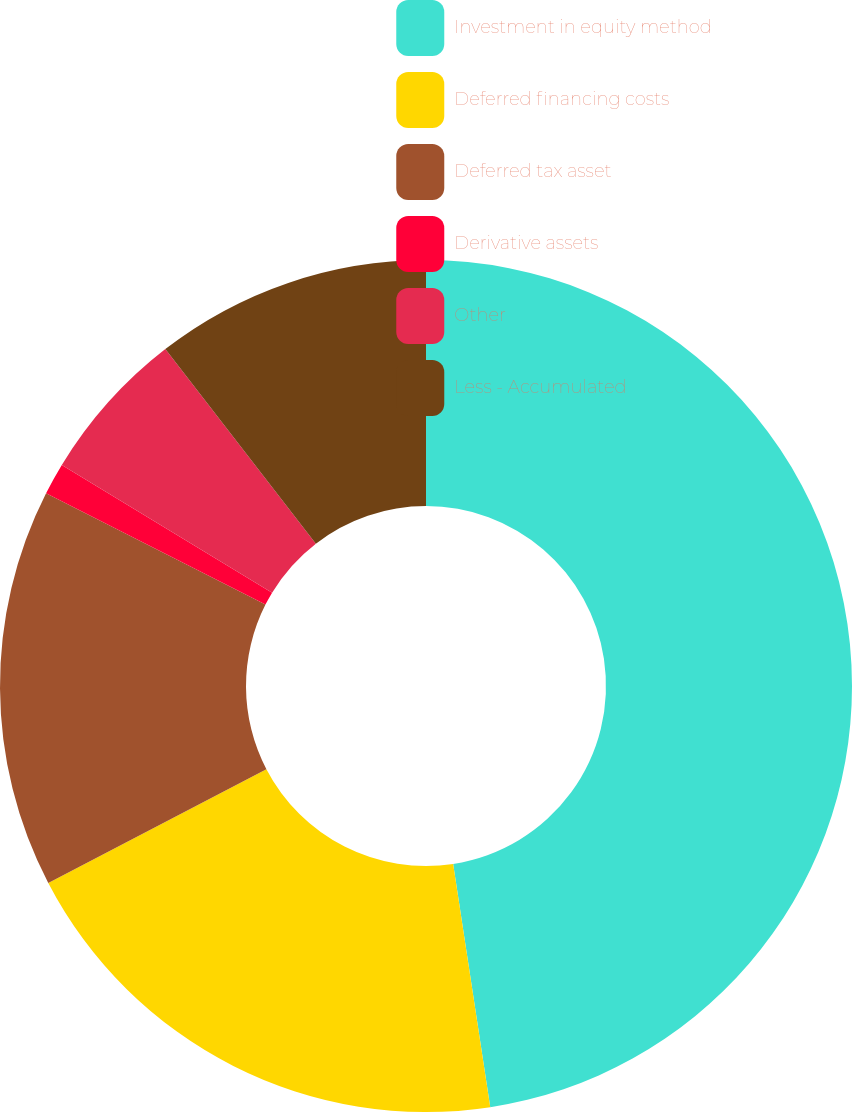Convert chart. <chart><loc_0><loc_0><loc_500><loc_500><pie_chart><fcel>Investment in equity method<fcel>Deferred financing costs<fcel>Deferred tax asset<fcel>Derivative assets<fcel>Other<fcel>Less - Accumulated<nl><fcel>47.59%<fcel>19.76%<fcel>15.12%<fcel>1.21%<fcel>5.84%<fcel>10.48%<nl></chart> 